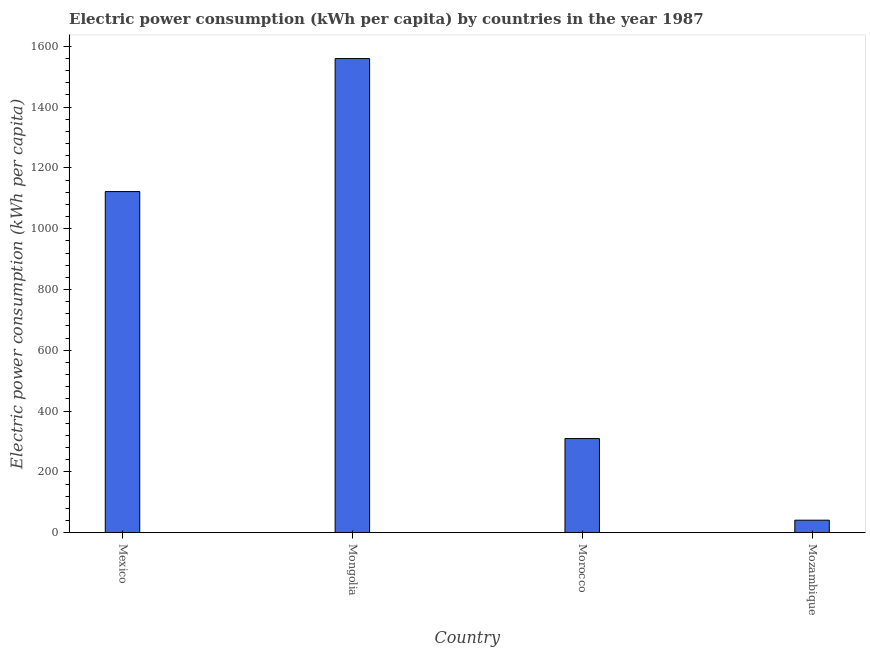Does the graph contain any zero values?
Your answer should be compact. No. What is the title of the graph?
Give a very brief answer. Electric power consumption (kWh per capita) by countries in the year 1987. What is the label or title of the X-axis?
Your response must be concise. Country. What is the label or title of the Y-axis?
Make the answer very short. Electric power consumption (kWh per capita). What is the electric power consumption in Morocco?
Make the answer very short. 309.71. Across all countries, what is the maximum electric power consumption?
Provide a succinct answer. 1559.5. Across all countries, what is the minimum electric power consumption?
Offer a terse response. 41.16. In which country was the electric power consumption maximum?
Make the answer very short. Mongolia. In which country was the electric power consumption minimum?
Provide a succinct answer. Mozambique. What is the sum of the electric power consumption?
Make the answer very short. 3032.45. What is the difference between the electric power consumption in Mexico and Mongolia?
Make the answer very short. -437.42. What is the average electric power consumption per country?
Provide a short and direct response. 758.11. What is the median electric power consumption?
Ensure brevity in your answer.  715.89. In how many countries, is the electric power consumption greater than 120 kWh per capita?
Offer a very short reply. 3. What is the ratio of the electric power consumption in Mongolia to that in Mozambique?
Make the answer very short. 37.88. What is the difference between the highest and the second highest electric power consumption?
Your answer should be very brief. 437.42. Is the sum of the electric power consumption in Mongolia and Mozambique greater than the maximum electric power consumption across all countries?
Provide a succinct answer. Yes. What is the difference between the highest and the lowest electric power consumption?
Your answer should be compact. 1518.34. In how many countries, is the electric power consumption greater than the average electric power consumption taken over all countries?
Your response must be concise. 2. Are the values on the major ticks of Y-axis written in scientific E-notation?
Provide a short and direct response. No. What is the Electric power consumption (kWh per capita) of Mexico?
Keep it short and to the point. 1122.08. What is the Electric power consumption (kWh per capita) in Mongolia?
Your answer should be very brief. 1559.5. What is the Electric power consumption (kWh per capita) of Morocco?
Ensure brevity in your answer.  309.71. What is the Electric power consumption (kWh per capita) of Mozambique?
Provide a short and direct response. 41.16. What is the difference between the Electric power consumption (kWh per capita) in Mexico and Mongolia?
Provide a short and direct response. -437.42. What is the difference between the Electric power consumption (kWh per capita) in Mexico and Morocco?
Provide a short and direct response. 812.37. What is the difference between the Electric power consumption (kWh per capita) in Mexico and Mozambique?
Offer a very short reply. 1080.91. What is the difference between the Electric power consumption (kWh per capita) in Mongolia and Morocco?
Offer a terse response. 1249.79. What is the difference between the Electric power consumption (kWh per capita) in Mongolia and Mozambique?
Offer a very short reply. 1518.34. What is the difference between the Electric power consumption (kWh per capita) in Morocco and Mozambique?
Provide a short and direct response. 268.54. What is the ratio of the Electric power consumption (kWh per capita) in Mexico to that in Mongolia?
Keep it short and to the point. 0.72. What is the ratio of the Electric power consumption (kWh per capita) in Mexico to that in Morocco?
Offer a terse response. 3.62. What is the ratio of the Electric power consumption (kWh per capita) in Mexico to that in Mozambique?
Offer a very short reply. 27.26. What is the ratio of the Electric power consumption (kWh per capita) in Mongolia to that in Morocco?
Your answer should be very brief. 5.04. What is the ratio of the Electric power consumption (kWh per capita) in Mongolia to that in Mozambique?
Make the answer very short. 37.88. What is the ratio of the Electric power consumption (kWh per capita) in Morocco to that in Mozambique?
Make the answer very short. 7.52. 